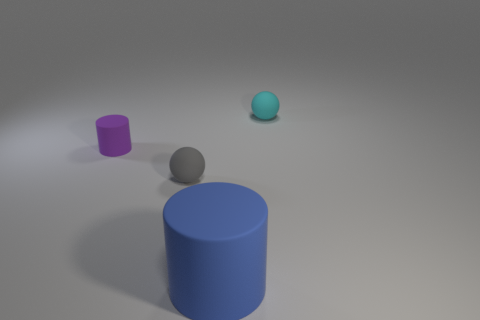Add 1 large matte objects. How many objects exist? 5 Subtract 2 spheres. How many spheres are left? 0 Subtract all blue cylinders. How many cylinders are left? 1 Subtract all gray cylinders. Subtract all brown cubes. How many cylinders are left? 2 Subtract all cyan balls. How many blue cylinders are left? 1 Subtract all blue shiny objects. Subtract all large cylinders. How many objects are left? 3 Add 3 small cyan balls. How many small cyan balls are left? 4 Add 4 rubber things. How many rubber things exist? 8 Subtract 0 green balls. How many objects are left? 4 